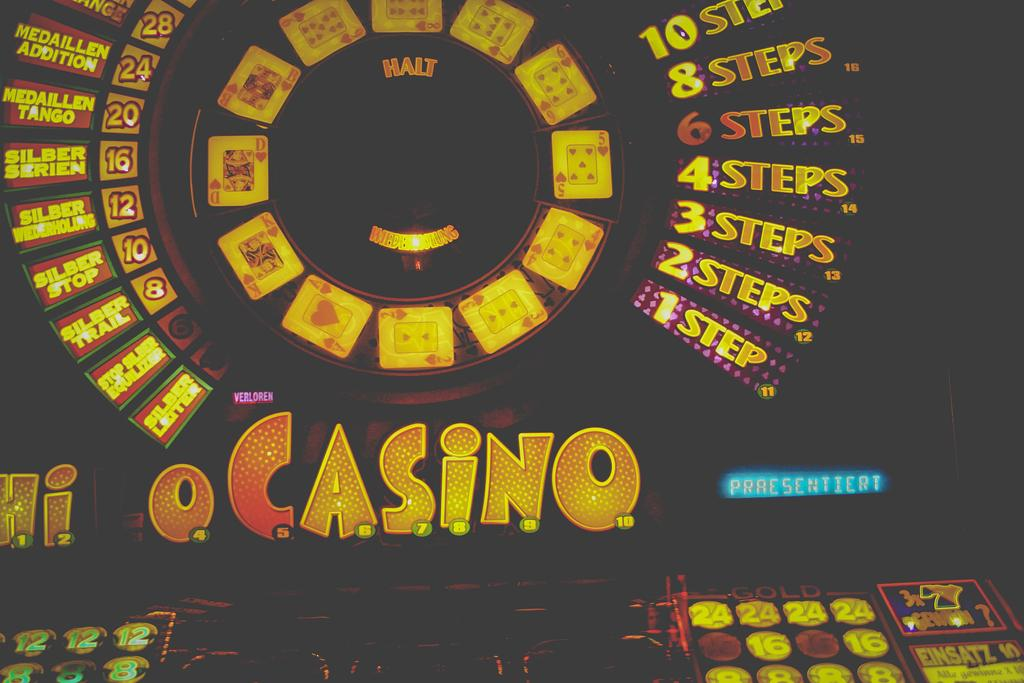<image>
Present a compact description of the photo's key features. casino game or some sort of machine for gambling 